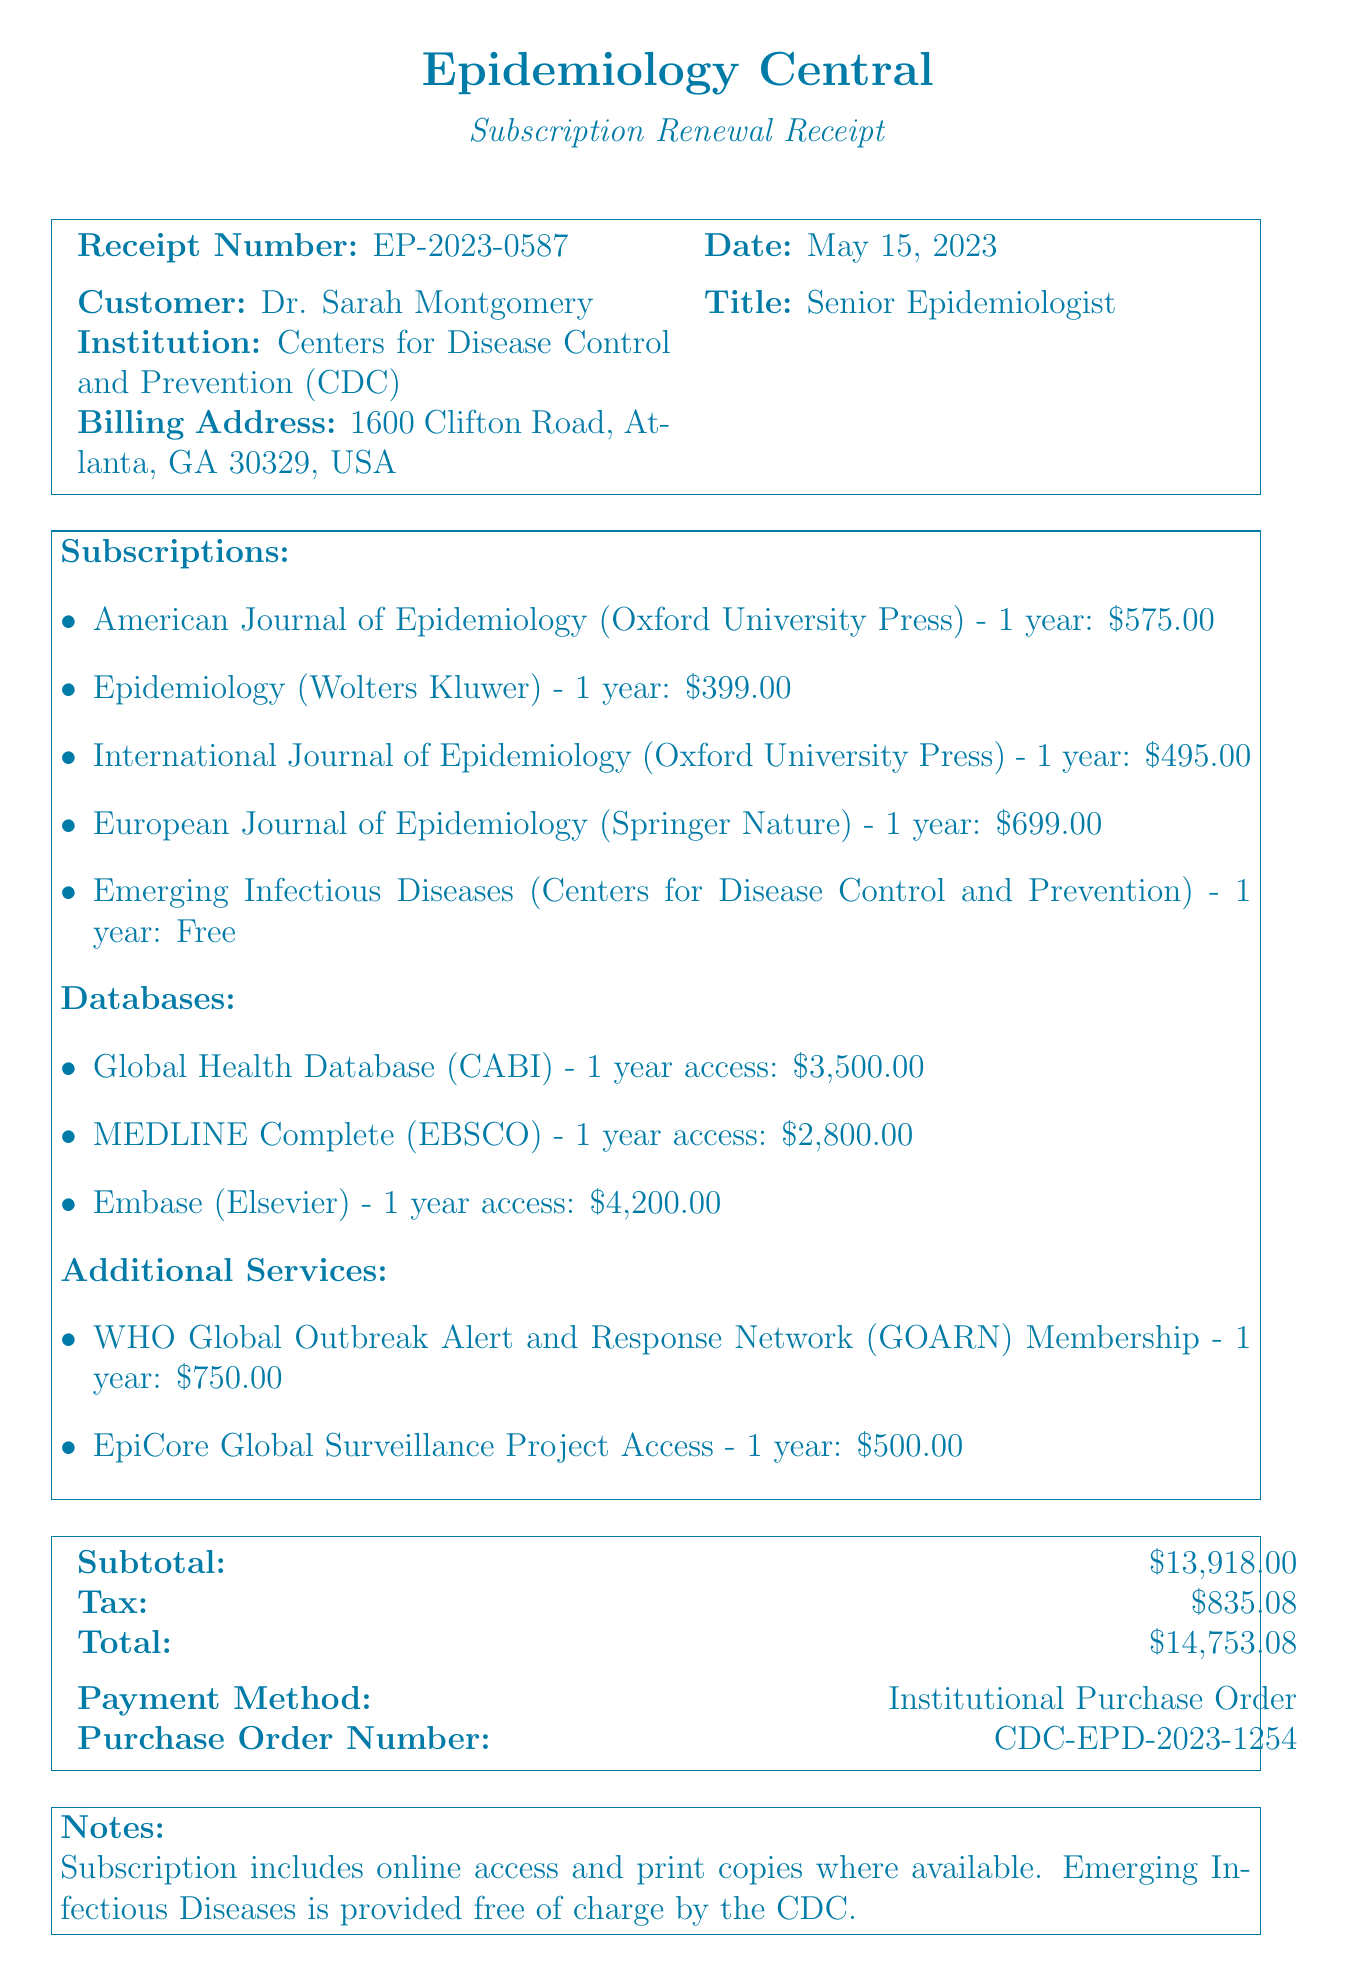What is the receipt number? The receipt number is listed at the top of the document.
Answer: EP-2023-0587 What is the total amount due? The total amount is found at the end of the receipt, summing up all charges including tax.
Answer: $14,753.08 How many subscriptions are included? The number of subscriptions is detailed under the subscriptions section.
Answer: 5 Who is the customer? The customer's name is presented in the customer information section.
Answer: Dr. Sarah Montgomery What is the price of the International Journal of Epidemiology? The price is mentioned in the subscriptions section.
Answer: $495.00 How much is the subscription for Emerging Infectious Diseases? It is specifically stated as free in the subscriptions section.
Answer: Free What is the payment method used? The payment method is clearly indicated in the financial summary section.
Answer: Institutional Purchase Order What is the provider of the Global Health Database? The provider is listed under the databases section.
Answer: CABI What is the duration of the WHO Global Outbreak Alert and Response Network membership? The duration is noted in the additional services section.
Answer: 1 year 